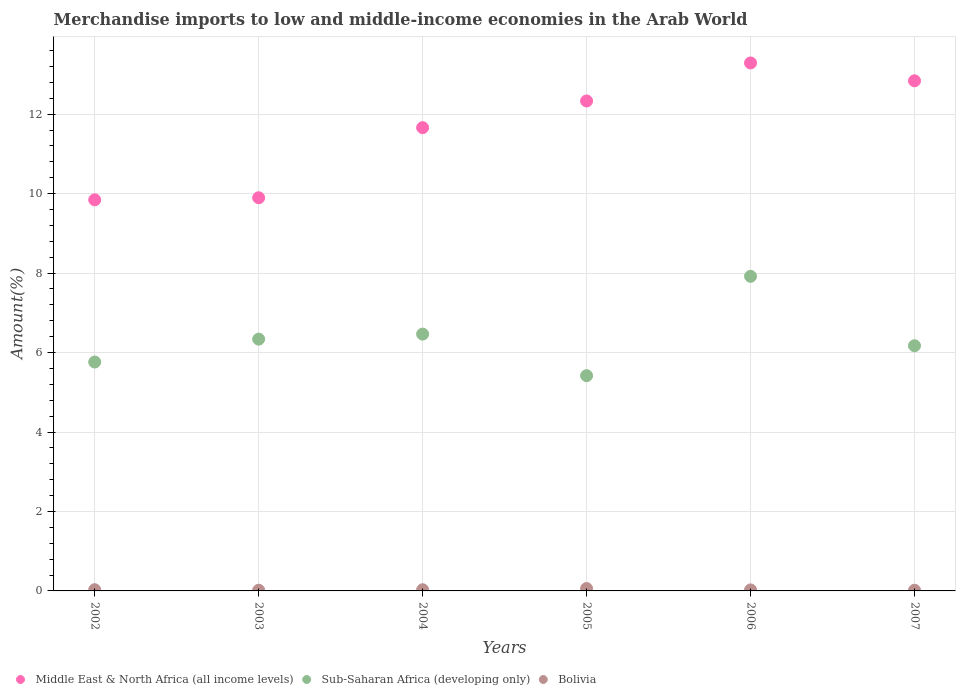What is the percentage of amount earned from merchandise imports in Middle East & North Africa (all income levels) in 2006?
Your answer should be very brief. 13.29. Across all years, what is the maximum percentage of amount earned from merchandise imports in Sub-Saharan Africa (developing only)?
Your answer should be compact. 7.92. Across all years, what is the minimum percentage of amount earned from merchandise imports in Sub-Saharan Africa (developing only)?
Give a very brief answer. 5.42. In which year was the percentage of amount earned from merchandise imports in Middle East & North Africa (all income levels) minimum?
Provide a succinct answer. 2002. What is the total percentage of amount earned from merchandise imports in Bolivia in the graph?
Give a very brief answer. 0.18. What is the difference between the percentage of amount earned from merchandise imports in Bolivia in 2002 and that in 2007?
Ensure brevity in your answer.  0.01. What is the difference between the percentage of amount earned from merchandise imports in Sub-Saharan Africa (developing only) in 2004 and the percentage of amount earned from merchandise imports in Bolivia in 2005?
Your answer should be compact. 6.4. What is the average percentage of amount earned from merchandise imports in Middle East & North Africa (all income levels) per year?
Your answer should be very brief. 11.64. In the year 2006, what is the difference between the percentage of amount earned from merchandise imports in Middle East & North Africa (all income levels) and percentage of amount earned from merchandise imports in Bolivia?
Give a very brief answer. 13.26. In how many years, is the percentage of amount earned from merchandise imports in Middle East & North Africa (all income levels) greater than 10 %?
Give a very brief answer. 4. What is the ratio of the percentage of amount earned from merchandise imports in Bolivia in 2003 to that in 2006?
Provide a short and direct response. 0.68. Is the percentage of amount earned from merchandise imports in Sub-Saharan Africa (developing only) in 2004 less than that in 2006?
Your answer should be very brief. Yes. What is the difference between the highest and the second highest percentage of amount earned from merchandise imports in Sub-Saharan Africa (developing only)?
Ensure brevity in your answer.  1.45. What is the difference between the highest and the lowest percentage of amount earned from merchandise imports in Sub-Saharan Africa (developing only)?
Provide a short and direct response. 2.5. In how many years, is the percentage of amount earned from merchandise imports in Sub-Saharan Africa (developing only) greater than the average percentage of amount earned from merchandise imports in Sub-Saharan Africa (developing only) taken over all years?
Offer a very short reply. 2. Is the sum of the percentage of amount earned from merchandise imports in Middle East & North Africa (all income levels) in 2004 and 2005 greater than the maximum percentage of amount earned from merchandise imports in Sub-Saharan Africa (developing only) across all years?
Your answer should be very brief. Yes. Is the percentage of amount earned from merchandise imports in Middle East & North Africa (all income levels) strictly less than the percentage of amount earned from merchandise imports in Sub-Saharan Africa (developing only) over the years?
Provide a succinct answer. No. What is the difference between two consecutive major ticks on the Y-axis?
Give a very brief answer. 2. How many legend labels are there?
Offer a very short reply. 3. What is the title of the graph?
Give a very brief answer. Merchandise imports to low and middle-income economies in the Arab World. Does "Samoa" appear as one of the legend labels in the graph?
Give a very brief answer. No. What is the label or title of the Y-axis?
Provide a succinct answer. Amount(%). What is the Amount(%) in Middle East & North Africa (all income levels) in 2002?
Provide a succinct answer. 9.84. What is the Amount(%) in Sub-Saharan Africa (developing only) in 2002?
Offer a very short reply. 5.76. What is the Amount(%) in Bolivia in 2002?
Make the answer very short. 0.03. What is the Amount(%) in Middle East & North Africa (all income levels) in 2003?
Your answer should be very brief. 9.9. What is the Amount(%) in Sub-Saharan Africa (developing only) in 2003?
Give a very brief answer. 6.34. What is the Amount(%) of Bolivia in 2003?
Your answer should be very brief. 0.02. What is the Amount(%) in Middle East & North Africa (all income levels) in 2004?
Offer a very short reply. 11.66. What is the Amount(%) of Sub-Saharan Africa (developing only) in 2004?
Ensure brevity in your answer.  6.46. What is the Amount(%) of Bolivia in 2004?
Make the answer very short. 0.03. What is the Amount(%) of Middle East & North Africa (all income levels) in 2005?
Give a very brief answer. 12.33. What is the Amount(%) of Sub-Saharan Africa (developing only) in 2005?
Offer a terse response. 5.42. What is the Amount(%) of Bolivia in 2005?
Offer a terse response. 0.06. What is the Amount(%) in Middle East & North Africa (all income levels) in 2006?
Keep it short and to the point. 13.29. What is the Amount(%) in Sub-Saharan Africa (developing only) in 2006?
Give a very brief answer. 7.92. What is the Amount(%) in Bolivia in 2006?
Your response must be concise. 0.03. What is the Amount(%) in Middle East & North Africa (all income levels) in 2007?
Offer a terse response. 12.84. What is the Amount(%) in Sub-Saharan Africa (developing only) in 2007?
Give a very brief answer. 6.17. What is the Amount(%) in Bolivia in 2007?
Make the answer very short. 0.02. Across all years, what is the maximum Amount(%) in Middle East & North Africa (all income levels)?
Your answer should be very brief. 13.29. Across all years, what is the maximum Amount(%) of Sub-Saharan Africa (developing only)?
Provide a short and direct response. 7.92. Across all years, what is the maximum Amount(%) of Bolivia?
Your answer should be compact. 0.06. Across all years, what is the minimum Amount(%) in Middle East & North Africa (all income levels)?
Give a very brief answer. 9.84. Across all years, what is the minimum Amount(%) of Sub-Saharan Africa (developing only)?
Your response must be concise. 5.42. Across all years, what is the minimum Amount(%) in Bolivia?
Provide a short and direct response. 0.02. What is the total Amount(%) of Middle East & North Africa (all income levels) in the graph?
Provide a succinct answer. 69.86. What is the total Amount(%) of Sub-Saharan Africa (developing only) in the graph?
Your answer should be compact. 38.07. What is the total Amount(%) of Bolivia in the graph?
Give a very brief answer. 0.18. What is the difference between the Amount(%) in Middle East & North Africa (all income levels) in 2002 and that in 2003?
Provide a succinct answer. -0.05. What is the difference between the Amount(%) of Sub-Saharan Africa (developing only) in 2002 and that in 2003?
Your answer should be very brief. -0.58. What is the difference between the Amount(%) in Bolivia in 2002 and that in 2003?
Offer a very short reply. 0.01. What is the difference between the Amount(%) in Middle East & North Africa (all income levels) in 2002 and that in 2004?
Offer a very short reply. -1.82. What is the difference between the Amount(%) in Sub-Saharan Africa (developing only) in 2002 and that in 2004?
Your response must be concise. -0.7. What is the difference between the Amount(%) of Bolivia in 2002 and that in 2004?
Provide a short and direct response. 0. What is the difference between the Amount(%) in Middle East & North Africa (all income levels) in 2002 and that in 2005?
Provide a succinct answer. -2.49. What is the difference between the Amount(%) in Sub-Saharan Africa (developing only) in 2002 and that in 2005?
Make the answer very short. 0.34. What is the difference between the Amount(%) of Bolivia in 2002 and that in 2005?
Provide a succinct answer. -0.03. What is the difference between the Amount(%) of Middle East & North Africa (all income levels) in 2002 and that in 2006?
Offer a terse response. -3.45. What is the difference between the Amount(%) in Sub-Saharan Africa (developing only) in 2002 and that in 2006?
Ensure brevity in your answer.  -2.16. What is the difference between the Amount(%) in Bolivia in 2002 and that in 2006?
Your answer should be compact. 0.01. What is the difference between the Amount(%) of Middle East & North Africa (all income levels) in 2002 and that in 2007?
Offer a terse response. -3. What is the difference between the Amount(%) of Sub-Saharan Africa (developing only) in 2002 and that in 2007?
Offer a terse response. -0.41. What is the difference between the Amount(%) of Bolivia in 2002 and that in 2007?
Your answer should be very brief. 0.01. What is the difference between the Amount(%) in Middle East & North Africa (all income levels) in 2003 and that in 2004?
Provide a short and direct response. -1.76. What is the difference between the Amount(%) in Sub-Saharan Africa (developing only) in 2003 and that in 2004?
Offer a very short reply. -0.13. What is the difference between the Amount(%) of Bolivia in 2003 and that in 2004?
Ensure brevity in your answer.  -0.01. What is the difference between the Amount(%) in Middle East & North Africa (all income levels) in 2003 and that in 2005?
Your answer should be very brief. -2.44. What is the difference between the Amount(%) of Sub-Saharan Africa (developing only) in 2003 and that in 2005?
Ensure brevity in your answer.  0.92. What is the difference between the Amount(%) of Bolivia in 2003 and that in 2005?
Provide a short and direct response. -0.04. What is the difference between the Amount(%) of Middle East & North Africa (all income levels) in 2003 and that in 2006?
Offer a very short reply. -3.39. What is the difference between the Amount(%) of Sub-Saharan Africa (developing only) in 2003 and that in 2006?
Your answer should be compact. -1.58. What is the difference between the Amount(%) of Bolivia in 2003 and that in 2006?
Keep it short and to the point. -0.01. What is the difference between the Amount(%) of Middle East & North Africa (all income levels) in 2003 and that in 2007?
Keep it short and to the point. -2.94. What is the difference between the Amount(%) of Sub-Saharan Africa (developing only) in 2003 and that in 2007?
Provide a short and direct response. 0.17. What is the difference between the Amount(%) in Bolivia in 2003 and that in 2007?
Keep it short and to the point. -0. What is the difference between the Amount(%) in Middle East & North Africa (all income levels) in 2004 and that in 2005?
Keep it short and to the point. -0.67. What is the difference between the Amount(%) of Sub-Saharan Africa (developing only) in 2004 and that in 2005?
Ensure brevity in your answer.  1.05. What is the difference between the Amount(%) of Bolivia in 2004 and that in 2005?
Provide a succinct answer. -0.03. What is the difference between the Amount(%) in Middle East & North Africa (all income levels) in 2004 and that in 2006?
Offer a terse response. -1.63. What is the difference between the Amount(%) of Sub-Saharan Africa (developing only) in 2004 and that in 2006?
Your response must be concise. -1.45. What is the difference between the Amount(%) in Bolivia in 2004 and that in 2006?
Ensure brevity in your answer.  0. What is the difference between the Amount(%) in Middle East & North Africa (all income levels) in 2004 and that in 2007?
Make the answer very short. -1.18. What is the difference between the Amount(%) in Sub-Saharan Africa (developing only) in 2004 and that in 2007?
Make the answer very short. 0.29. What is the difference between the Amount(%) of Bolivia in 2004 and that in 2007?
Keep it short and to the point. 0.01. What is the difference between the Amount(%) in Middle East & North Africa (all income levels) in 2005 and that in 2006?
Ensure brevity in your answer.  -0.96. What is the difference between the Amount(%) of Sub-Saharan Africa (developing only) in 2005 and that in 2006?
Give a very brief answer. -2.5. What is the difference between the Amount(%) in Bolivia in 2005 and that in 2006?
Offer a terse response. 0.03. What is the difference between the Amount(%) of Middle East & North Africa (all income levels) in 2005 and that in 2007?
Keep it short and to the point. -0.51. What is the difference between the Amount(%) of Sub-Saharan Africa (developing only) in 2005 and that in 2007?
Your answer should be compact. -0.75. What is the difference between the Amount(%) in Bolivia in 2005 and that in 2007?
Ensure brevity in your answer.  0.04. What is the difference between the Amount(%) in Middle East & North Africa (all income levels) in 2006 and that in 2007?
Make the answer very short. 0.45. What is the difference between the Amount(%) in Sub-Saharan Africa (developing only) in 2006 and that in 2007?
Offer a very short reply. 1.75. What is the difference between the Amount(%) in Bolivia in 2006 and that in 2007?
Your answer should be compact. 0.01. What is the difference between the Amount(%) of Middle East & North Africa (all income levels) in 2002 and the Amount(%) of Sub-Saharan Africa (developing only) in 2003?
Offer a very short reply. 3.51. What is the difference between the Amount(%) in Middle East & North Africa (all income levels) in 2002 and the Amount(%) in Bolivia in 2003?
Provide a short and direct response. 9.83. What is the difference between the Amount(%) of Sub-Saharan Africa (developing only) in 2002 and the Amount(%) of Bolivia in 2003?
Your answer should be very brief. 5.74. What is the difference between the Amount(%) in Middle East & North Africa (all income levels) in 2002 and the Amount(%) in Sub-Saharan Africa (developing only) in 2004?
Your answer should be very brief. 3.38. What is the difference between the Amount(%) in Middle East & North Africa (all income levels) in 2002 and the Amount(%) in Bolivia in 2004?
Your answer should be compact. 9.81. What is the difference between the Amount(%) of Sub-Saharan Africa (developing only) in 2002 and the Amount(%) of Bolivia in 2004?
Ensure brevity in your answer.  5.73. What is the difference between the Amount(%) of Middle East & North Africa (all income levels) in 2002 and the Amount(%) of Sub-Saharan Africa (developing only) in 2005?
Your response must be concise. 4.43. What is the difference between the Amount(%) in Middle East & North Africa (all income levels) in 2002 and the Amount(%) in Bolivia in 2005?
Give a very brief answer. 9.78. What is the difference between the Amount(%) in Sub-Saharan Africa (developing only) in 2002 and the Amount(%) in Bolivia in 2005?
Offer a very short reply. 5.7. What is the difference between the Amount(%) in Middle East & North Africa (all income levels) in 2002 and the Amount(%) in Sub-Saharan Africa (developing only) in 2006?
Make the answer very short. 1.93. What is the difference between the Amount(%) of Middle East & North Africa (all income levels) in 2002 and the Amount(%) of Bolivia in 2006?
Your answer should be compact. 9.82. What is the difference between the Amount(%) of Sub-Saharan Africa (developing only) in 2002 and the Amount(%) of Bolivia in 2006?
Offer a terse response. 5.74. What is the difference between the Amount(%) in Middle East & North Africa (all income levels) in 2002 and the Amount(%) in Sub-Saharan Africa (developing only) in 2007?
Offer a terse response. 3.67. What is the difference between the Amount(%) in Middle East & North Africa (all income levels) in 2002 and the Amount(%) in Bolivia in 2007?
Offer a very short reply. 9.83. What is the difference between the Amount(%) of Sub-Saharan Africa (developing only) in 2002 and the Amount(%) of Bolivia in 2007?
Provide a succinct answer. 5.74. What is the difference between the Amount(%) in Middle East & North Africa (all income levels) in 2003 and the Amount(%) in Sub-Saharan Africa (developing only) in 2004?
Ensure brevity in your answer.  3.43. What is the difference between the Amount(%) in Middle East & North Africa (all income levels) in 2003 and the Amount(%) in Bolivia in 2004?
Make the answer very short. 9.87. What is the difference between the Amount(%) of Sub-Saharan Africa (developing only) in 2003 and the Amount(%) of Bolivia in 2004?
Keep it short and to the point. 6.31. What is the difference between the Amount(%) of Middle East & North Africa (all income levels) in 2003 and the Amount(%) of Sub-Saharan Africa (developing only) in 2005?
Keep it short and to the point. 4.48. What is the difference between the Amount(%) in Middle East & North Africa (all income levels) in 2003 and the Amount(%) in Bolivia in 2005?
Your answer should be very brief. 9.84. What is the difference between the Amount(%) in Sub-Saharan Africa (developing only) in 2003 and the Amount(%) in Bolivia in 2005?
Make the answer very short. 6.28. What is the difference between the Amount(%) in Middle East & North Africa (all income levels) in 2003 and the Amount(%) in Sub-Saharan Africa (developing only) in 2006?
Keep it short and to the point. 1.98. What is the difference between the Amount(%) of Middle East & North Africa (all income levels) in 2003 and the Amount(%) of Bolivia in 2006?
Your response must be concise. 9.87. What is the difference between the Amount(%) in Sub-Saharan Africa (developing only) in 2003 and the Amount(%) in Bolivia in 2006?
Provide a short and direct response. 6.31. What is the difference between the Amount(%) in Middle East & North Africa (all income levels) in 2003 and the Amount(%) in Sub-Saharan Africa (developing only) in 2007?
Offer a very short reply. 3.72. What is the difference between the Amount(%) in Middle East & North Africa (all income levels) in 2003 and the Amount(%) in Bolivia in 2007?
Give a very brief answer. 9.88. What is the difference between the Amount(%) of Sub-Saharan Africa (developing only) in 2003 and the Amount(%) of Bolivia in 2007?
Offer a terse response. 6.32. What is the difference between the Amount(%) in Middle East & North Africa (all income levels) in 2004 and the Amount(%) in Sub-Saharan Africa (developing only) in 2005?
Your answer should be compact. 6.24. What is the difference between the Amount(%) of Middle East & North Africa (all income levels) in 2004 and the Amount(%) of Bolivia in 2005?
Offer a terse response. 11.6. What is the difference between the Amount(%) in Sub-Saharan Africa (developing only) in 2004 and the Amount(%) in Bolivia in 2005?
Your answer should be compact. 6.4. What is the difference between the Amount(%) in Middle East & North Africa (all income levels) in 2004 and the Amount(%) in Sub-Saharan Africa (developing only) in 2006?
Your answer should be compact. 3.74. What is the difference between the Amount(%) of Middle East & North Africa (all income levels) in 2004 and the Amount(%) of Bolivia in 2006?
Offer a terse response. 11.64. What is the difference between the Amount(%) of Sub-Saharan Africa (developing only) in 2004 and the Amount(%) of Bolivia in 2006?
Your response must be concise. 6.44. What is the difference between the Amount(%) of Middle East & North Africa (all income levels) in 2004 and the Amount(%) of Sub-Saharan Africa (developing only) in 2007?
Give a very brief answer. 5.49. What is the difference between the Amount(%) in Middle East & North Africa (all income levels) in 2004 and the Amount(%) in Bolivia in 2007?
Ensure brevity in your answer.  11.64. What is the difference between the Amount(%) in Sub-Saharan Africa (developing only) in 2004 and the Amount(%) in Bolivia in 2007?
Give a very brief answer. 6.45. What is the difference between the Amount(%) in Middle East & North Africa (all income levels) in 2005 and the Amount(%) in Sub-Saharan Africa (developing only) in 2006?
Make the answer very short. 4.41. What is the difference between the Amount(%) in Middle East & North Africa (all income levels) in 2005 and the Amount(%) in Bolivia in 2006?
Keep it short and to the point. 12.31. What is the difference between the Amount(%) of Sub-Saharan Africa (developing only) in 2005 and the Amount(%) of Bolivia in 2006?
Offer a very short reply. 5.39. What is the difference between the Amount(%) of Middle East & North Africa (all income levels) in 2005 and the Amount(%) of Sub-Saharan Africa (developing only) in 2007?
Make the answer very short. 6.16. What is the difference between the Amount(%) in Middle East & North Africa (all income levels) in 2005 and the Amount(%) in Bolivia in 2007?
Offer a terse response. 12.32. What is the difference between the Amount(%) of Sub-Saharan Africa (developing only) in 2005 and the Amount(%) of Bolivia in 2007?
Provide a succinct answer. 5.4. What is the difference between the Amount(%) of Middle East & North Africa (all income levels) in 2006 and the Amount(%) of Sub-Saharan Africa (developing only) in 2007?
Keep it short and to the point. 7.12. What is the difference between the Amount(%) of Middle East & North Africa (all income levels) in 2006 and the Amount(%) of Bolivia in 2007?
Offer a very short reply. 13.27. What is the difference between the Amount(%) in Sub-Saharan Africa (developing only) in 2006 and the Amount(%) in Bolivia in 2007?
Make the answer very short. 7.9. What is the average Amount(%) in Middle East & North Africa (all income levels) per year?
Offer a terse response. 11.64. What is the average Amount(%) of Sub-Saharan Africa (developing only) per year?
Keep it short and to the point. 6.35. What is the average Amount(%) in Bolivia per year?
Make the answer very short. 0.03. In the year 2002, what is the difference between the Amount(%) of Middle East & North Africa (all income levels) and Amount(%) of Sub-Saharan Africa (developing only)?
Keep it short and to the point. 4.08. In the year 2002, what is the difference between the Amount(%) in Middle East & North Africa (all income levels) and Amount(%) in Bolivia?
Your answer should be compact. 9.81. In the year 2002, what is the difference between the Amount(%) in Sub-Saharan Africa (developing only) and Amount(%) in Bolivia?
Offer a terse response. 5.73. In the year 2003, what is the difference between the Amount(%) of Middle East & North Africa (all income levels) and Amount(%) of Sub-Saharan Africa (developing only)?
Keep it short and to the point. 3.56. In the year 2003, what is the difference between the Amount(%) of Middle East & North Africa (all income levels) and Amount(%) of Bolivia?
Provide a short and direct response. 9.88. In the year 2003, what is the difference between the Amount(%) in Sub-Saharan Africa (developing only) and Amount(%) in Bolivia?
Your answer should be compact. 6.32. In the year 2004, what is the difference between the Amount(%) in Middle East & North Africa (all income levels) and Amount(%) in Sub-Saharan Africa (developing only)?
Provide a succinct answer. 5.2. In the year 2004, what is the difference between the Amount(%) in Middle East & North Africa (all income levels) and Amount(%) in Bolivia?
Your answer should be compact. 11.63. In the year 2004, what is the difference between the Amount(%) in Sub-Saharan Africa (developing only) and Amount(%) in Bolivia?
Offer a very short reply. 6.43. In the year 2005, what is the difference between the Amount(%) in Middle East & North Africa (all income levels) and Amount(%) in Sub-Saharan Africa (developing only)?
Your answer should be very brief. 6.91. In the year 2005, what is the difference between the Amount(%) in Middle East & North Africa (all income levels) and Amount(%) in Bolivia?
Your answer should be very brief. 12.27. In the year 2005, what is the difference between the Amount(%) of Sub-Saharan Africa (developing only) and Amount(%) of Bolivia?
Your response must be concise. 5.36. In the year 2006, what is the difference between the Amount(%) of Middle East & North Africa (all income levels) and Amount(%) of Sub-Saharan Africa (developing only)?
Keep it short and to the point. 5.37. In the year 2006, what is the difference between the Amount(%) of Middle East & North Africa (all income levels) and Amount(%) of Bolivia?
Provide a succinct answer. 13.26. In the year 2006, what is the difference between the Amount(%) in Sub-Saharan Africa (developing only) and Amount(%) in Bolivia?
Make the answer very short. 7.89. In the year 2007, what is the difference between the Amount(%) of Middle East & North Africa (all income levels) and Amount(%) of Sub-Saharan Africa (developing only)?
Make the answer very short. 6.67. In the year 2007, what is the difference between the Amount(%) of Middle East & North Africa (all income levels) and Amount(%) of Bolivia?
Keep it short and to the point. 12.82. In the year 2007, what is the difference between the Amount(%) of Sub-Saharan Africa (developing only) and Amount(%) of Bolivia?
Keep it short and to the point. 6.15. What is the ratio of the Amount(%) of Middle East & North Africa (all income levels) in 2002 to that in 2003?
Your answer should be compact. 0.99. What is the ratio of the Amount(%) of Bolivia in 2002 to that in 2003?
Provide a succinct answer. 1.81. What is the ratio of the Amount(%) in Middle East & North Africa (all income levels) in 2002 to that in 2004?
Ensure brevity in your answer.  0.84. What is the ratio of the Amount(%) of Sub-Saharan Africa (developing only) in 2002 to that in 2004?
Offer a very short reply. 0.89. What is the ratio of the Amount(%) of Bolivia in 2002 to that in 2004?
Ensure brevity in your answer.  1.04. What is the ratio of the Amount(%) in Middle East & North Africa (all income levels) in 2002 to that in 2005?
Give a very brief answer. 0.8. What is the ratio of the Amount(%) of Sub-Saharan Africa (developing only) in 2002 to that in 2005?
Provide a succinct answer. 1.06. What is the ratio of the Amount(%) of Bolivia in 2002 to that in 2005?
Your answer should be compact. 0.52. What is the ratio of the Amount(%) of Middle East & North Africa (all income levels) in 2002 to that in 2006?
Give a very brief answer. 0.74. What is the ratio of the Amount(%) in Sub-Saharan Africa (developing only) in 2002 to that in 2006?
Your answer should be very brief. 0.73. What is the ratio of the Amount(%) of Bolivia in 2002 to that in 2006?
Ensure brevity in your answer.  1.22. What is the ratio of the Amount(%) of Middle East & North Africa (all income levels) in 2002 to that in 2007?
Make the answer very short. 0.77. What is the ratio of the Amount(%) of Sub-Saharan Africa (developing only) in 2002 to that in 2007?
Make the answer very short. 0.93. What is the ratio of the Amount(%) of Bolivia in 2002 to that in 2007?
Ensure brevity in your answer.  1.8. What is the ratio of the Amount(%) of Middle East & North Africa (all income levels) in 2003 to that in 2004?
Make the answer very short. 0.85. What is the ratio of the Amount(%) of Sub-Saharan Africa (developing only) in 2003 to that in 2004?
Your answer should be very brief. 0.98. What is the ratio of the Amount(%) in Bolivia in 2003 to that in 2004?
Offer a very short reply. 0.57. What is the ratio of the Amount(%) in Middle East & North Africa (all income levels) in 2003 to that in 2005?
Your answer should be very brief. 0.8. What is the ratio of the Amount(%) in Sub-Saharan Africa (developing only) in 2003 to that in 2005?
Make the answer very short. 1.17. What is the ratio of the Amount(%) of Bolivia in 2003 to that in 2005?
Offer a very short reply. 0.28. What is the ratio of the Amount(%) of Middle East & North Africa (all income levels) in 2003 to that in 2006?
Your response must be concise. 0.74. What is the ratio of the Amount(%) in Sub-Saharan Africa (developing only) in 2003 to that in 2006?
Keep it short and to the point. 0.8. What is the ratio of the Amount(%) in Bolivia in 2003 to that in 2006?
Give a very brief answer. 0.68. What is the ratio of the Amount(%) of Middle East & North Africa (all income levels) in 2003 to that in 2007?
Keep it short and to the point. 0.77. What is the ratio of the Amount(%) in Sub-Saharan Africa (developing only) in 2003 to that in 2007?
Your response must be concise. 1.03. What is the ratio of the Amount(%) of Middle East & North Africa (all income levels) in 2004 to that in 2005?
Keep it short and to the point. 0.95. What is the ratio of the Amount(%) of Sub-Saharan Africa (developing only) in 2004 to that in 2005?
Make the answer very short. 1.19. What is the ratio of the Amount(%) in Bolivia in 2004 to that in 2005?
Offer a terse response. 0.5. What is the ratio of the Amount(%) in Middle East & North Africa (all income levels) in 2004 to that in 2006?
Your response must be concise. 0.88. What is the ratio of the Amount(%) of Sub-Saharan Africa (developing only) in 2004 to that in 2006?
Make the answer very short. 0.82. What is the ratio of the Amount(%) of Bolivia in 2004 to that in 2006?
Your answer should be very brief. 1.18. What is the ratio of the Amount(%) in Middle East & North Africa (all income levels) in 2004 to that in 2007?
Provide a short and direct response. 0.91. What is the ratio of the Amount(%) of Sub-Saharan Africa (developing only) in 2004 to that in 2007?
Your response must be concise. 1.05. What is the ratio of the Amount(%) in Bolivia in 2004 to that in 2007?
Your answer should be very brief. 1.74. What is the ratio of the Amount(%) of Middle East & North Africa (all income levels) in 2005 to that in 2006?
Make the answer very short. 0.93. What is the ratio of the Amount(%) of Sub-Saharan Africa (developing only) in 2005 to that in 2006?
Offer a terse response. 0.68. What is the ratio of the Amount(%) of Bolivia in 2005 to that in 2006?
Give a very brief answer. 2.37. What is the ratio of the Amount(%) in Middle East & North Africa (all income levels) in 2005 to that in 2007?
Keep it short and to the point. 0.96. What is the ratio of the Amount(%) of Sub-Saharan Africa (developing only) in 2005 to that in 2007?
Give a very brief answer. 0.88. What is the ratio of the Amount(%) in Bolivia in 2005 to that in 2007?
Your answer should be very brief. 3.5. What is the ratio of the Amount(%) of Middle East & North Africa (all income levels) in 2006 to that in 2007?
Provide a succinct answer. 1.03. What is the ratio of the Amount(%) in Sub-Saharan Africa (developing only) in 2006 to that in 2007?
Offer a terse response. 1.28. What is the ratio of the Amount(%) in Bolivia in 2006 to that in 2007?
Make the answer very short. 1.47. What is the difference between the highest and the second highest Amount(%) of Middle East & North Africa (all income levels)?
Make the answer very short. 0.45. What is the difference between the highest and the second highest Amount(%) in Sub-Saharan Africa (developing only)?
Your answer should be very brief. 1.45. What is the difference between the highest and the second highest Amount(%) in Bolivia?
Give a very brief answer. 0.03. What is the difference between the highest and the lowest Amount(%) in Middle East & North Africa (all income levels)?
Provide a short and direct response. 3.45. What is the difference between the highest and the lowest Amount(%) of Sub-Saharan Africa (developing only)?
Your answer should be very brief. 2.5. What is the difference between the highest and the lowest Amount(%) of Bolivia?
Give a very brief answer. 0.04. 